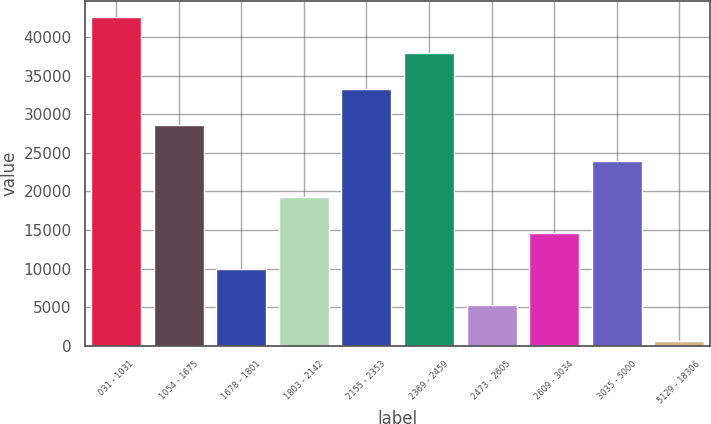Convert chart to OTSL. <chart><loc_0><loc_0><loc_500><loc_500><bar_chart><fcel>031 - 1031<fcel>1054 - 1675<fcel>1678 - 1801<fcel>1803 - 2142<fcel>2155 - 2353<fcel>2369 - 2459<fcel>2473 - 2605<fcel>2609 - 3034<fcel>3035 - 5000<fcel>5129 - 18306<nl><fcel>42516.3<fcel>28537.2<fcel>9898.4<fcel>19217.8<fcel>33196.9<fcel>37856.6<fcel>5238.7<fcel>14558.1<fcel>23877.5<fcel>579<nl></chart> 